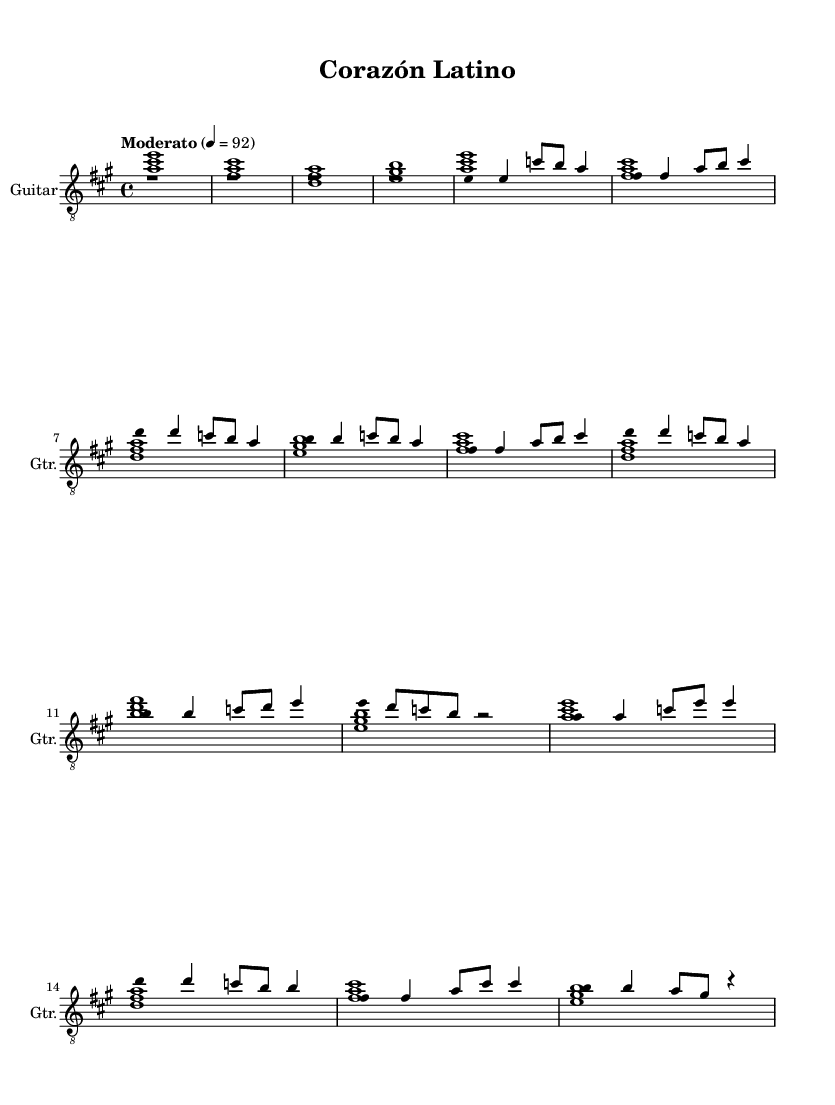What is the key signature of this music? The key signature shows A major, which has three sharps (F#, C#, and G#). This is indicated at the beginning of the staff.
Answer: A major What is the time signature of this music? The time signature, found after the clef, is 4/4. This means there are four beats in each measure and the quarter note gets one beat.
Answer: 4/4 What is the tempo marking of this piece? The tempo marking indicates "Moderato" with a metronome marking of 4 = 92, which gives a moderate speed for performing the piece.
Answer: Moderato How many measures does the melody contain? By counting the groupings of music separated by bar lines, the melody has a total of 8 measures.
Answer: 8 What is the first chord in the chord progression? The first chord in the chord progression is A major, as indicated in the chord mode section of the score.
Answer: A Which part of the song has the lyrics "Ba – jo el sol de la pla – ya"? This lyric corresponds to the very first measure of the melody part, where it begins the vocal line.
Answer: First measure What is the overall mood of this music piece? The combination of the key signature, tempo, and lyrical content contributes to a romantic mood, typical for love songs in contemporary Latin pop.
Answer: Romantic 